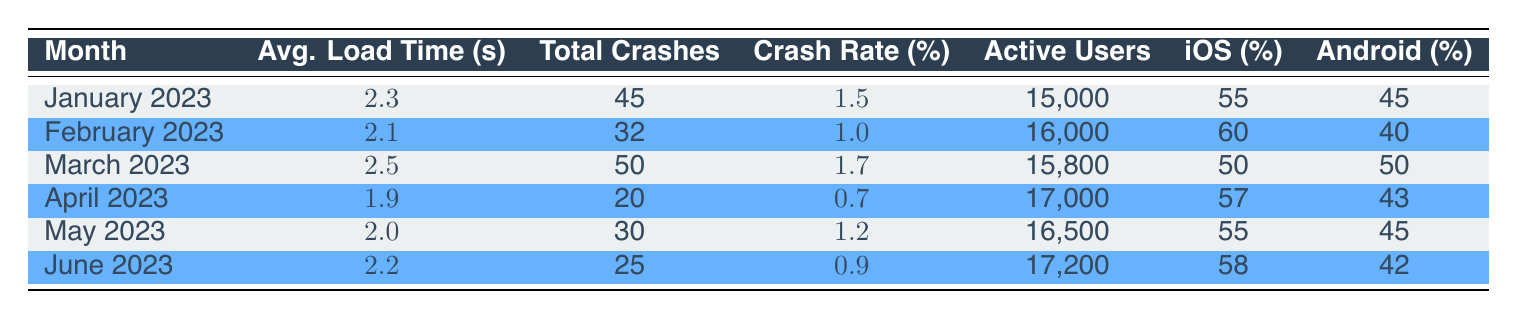What was the average load time in April 2023? The table shows that the average load time in April 2023 is listed directly under the "Avg. Load Time (s)" column for that month, which is 1.9 seconds.
Answer: 1.9 seconds Which month had the highest total number of crashes? By looking at the "Total Crashes" column for all months, March 2023 has the highest value at 50 crashes, compared to other months.
Answer: March 2023 What was the crash rate percentage in February 2023? The crash rate percentage for February 2023 is directly shown in the "Crash Rate (%)" column for that month, which is 1.0 percent.
Answer: 1.0 percent Which month had more active users: June 2023 or January 2023? January 2023 had 15,000 active users while June 2023 had 17,200 active users. Since 17,200 is greater than 15,000, June 2023 had more active users.
Answer: June 2023 What was the average load time across all months listed? To find the average load time, we sum all average load times: (2.3 + 2.1 + 2.5 + 1.9 + 2.0 + 2.2) = 13.0 seconds. Then divide by the number of months (6): 13.0 / 6 = 2.17 seconds.
Answer: 2.17 seconds Did the crash rate decrease from January 2023 to April 2023? The crash rate for January 2023 is 1.5 percent, and for April 2023, it is 0.7 percent. Since 0.7 is less than 1.5, the crash rate did decrease.
Answer: Yes In which month was the percentage of iOS users the highest? Referring to the "iOS (%)" column, February 2023 has the highest percentage of iOS users at 60 percent, compared to other months.
Answer: February 2023 What was the change in total crashes from June 2023 to March 2023? June 2023 had 25 crashes, and March 2023 had 50 crashes. To find the change, we subtract the number of crashes in June from the number in March: 50 - 25 = 25.
Answer: 25 crashes Which month had the lowest average load time, and what was that time? The month with the lowest average load time is April 2023, with the average load time listed as 1.9 seconds.
Answer: April 2023, 1.9 seconds 